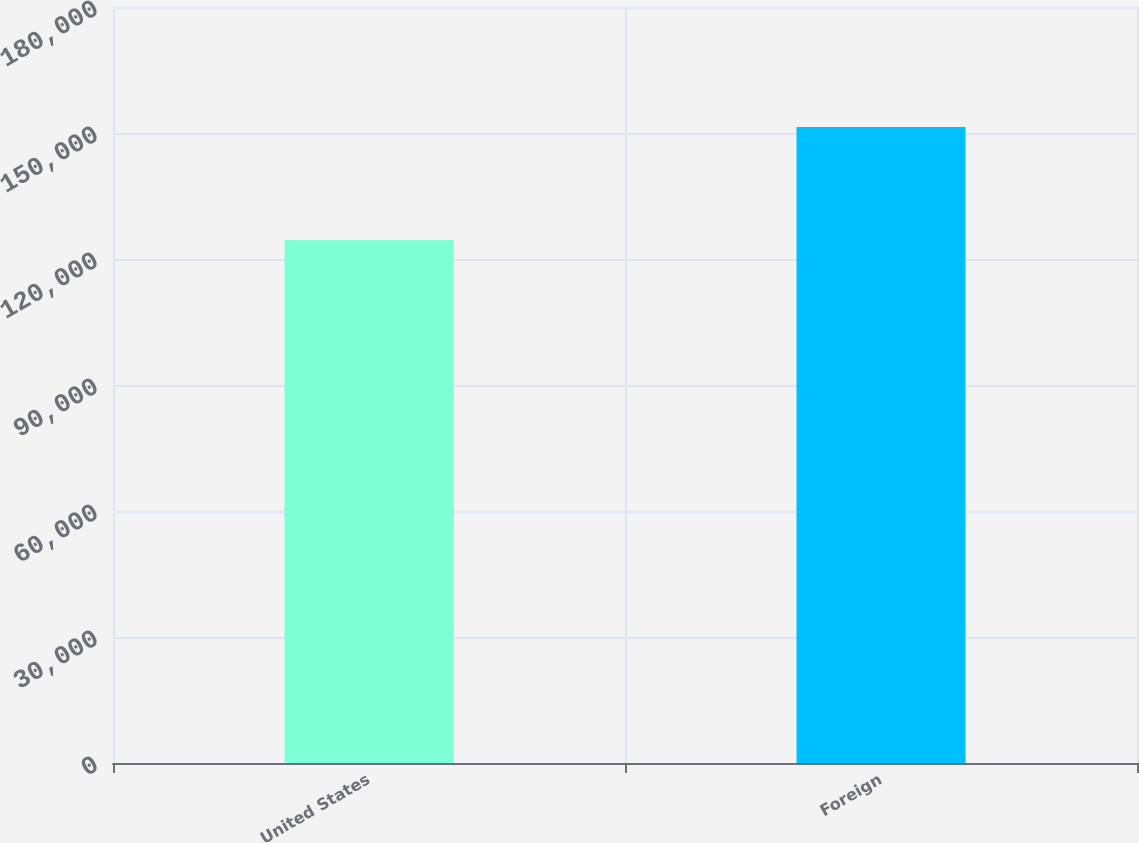<chart> <loc_0><loc_0><loc_500><loc_500><bar_chart><fcel>United States<fcel>Foreign<nl><fcel>124500<fcel>151457<nl></chart> 